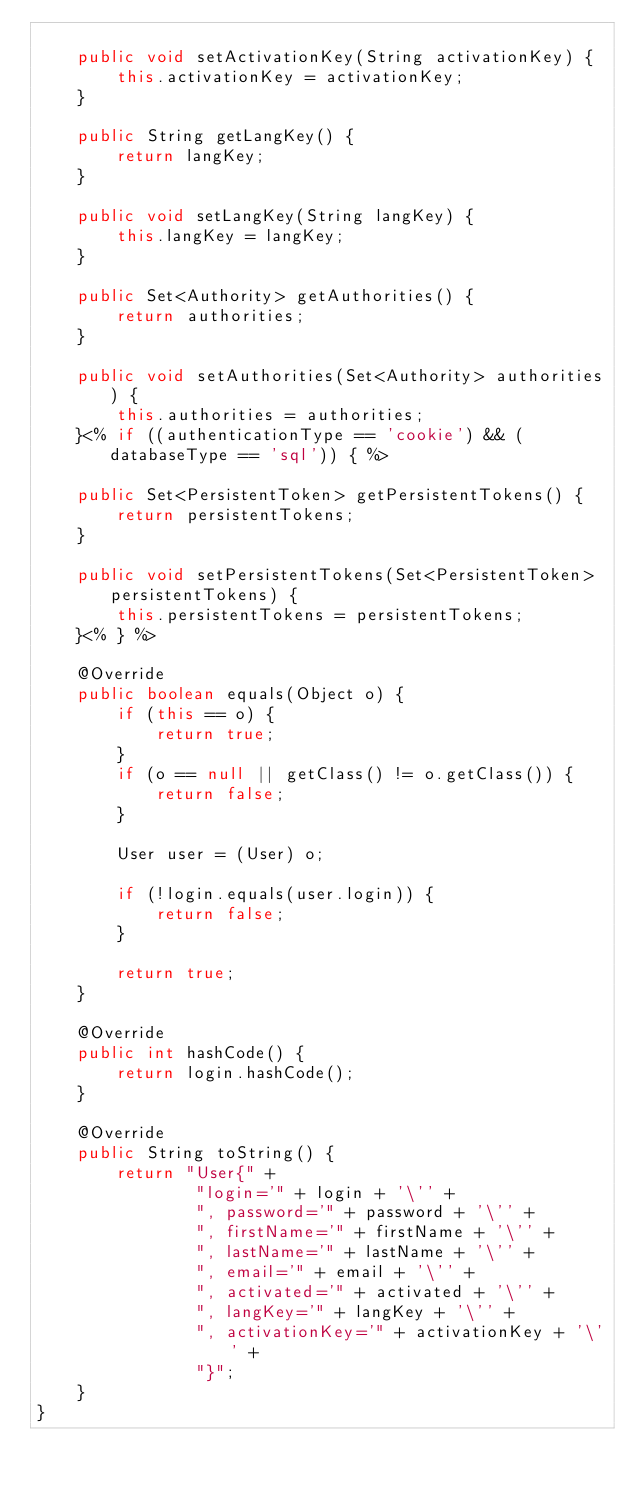<code> <loc_0><loc_0><loc_500><loc_500><_Java_>
    public void setActivationKey(String activationKey) {
        this.activationKey = activationKey;
    }

    public String getLangKey() {
        return langKey;
    }

    public void setLangKey(String langKey) {
        this.langKey = langKey;
    }

    public Set<Authority> getAuthorities() {
        return authorities;
    }

    public void setAuthorities(Set<Authority> authorities) {
        this.authorities = authorities;
    }<% if ((authenticationType == 'cookie') && (databaseType == 'sql')) { %>

    public Set<PersistentToken> getPersistentTokens() {
        return persistentTokens;
    }

    public void setPersistentTokens(Set<PersistentToken> persistentTokens) {
        this.persistentTokens = persistentTokens;
    }<% } %>

    @Override
    public boolean equals(Object o) {
        if (this == o) {
            return true;
        }
        if (o == null || getClass() != o.getClass()) {
            return false;
        }

        User user = (User) o;

        if (!login.equals(user.login)) {
            return false;
        }

        return true;
    }

    @Override
    public int hashCode() {
        return login.hashCode();
    }

    @Override
    public String toString() {
        return "User{" +
                "login='" + login + '\'' +
                ", password='" + password + '\'' +
                ", firstName='" + firstName + '\'' +
                ", lastName='" + lastName + '\'' +
                ", email='" + email + '\'' +
                ", activated='" + activated + '\'' +
                ", langKey='" + langKey + '\'' +
                ", activationKey='" + activationKey + '\'' +
                "}";
    }
}
</code> 